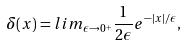<formula> <loc_0><loc_0><loc_500><loc_500>\delta ( x ) = l i m _ { \epsilon \rightarrow 0 ^ { + } } \frac { 1 } { 2 \epsilon } e ^ { - | x | / \epsilon } ,</formula> 